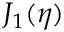<formula> <loc_0><loc_0><loc_500><loc_500>J _ { 1 } ( \eta )</formula> 